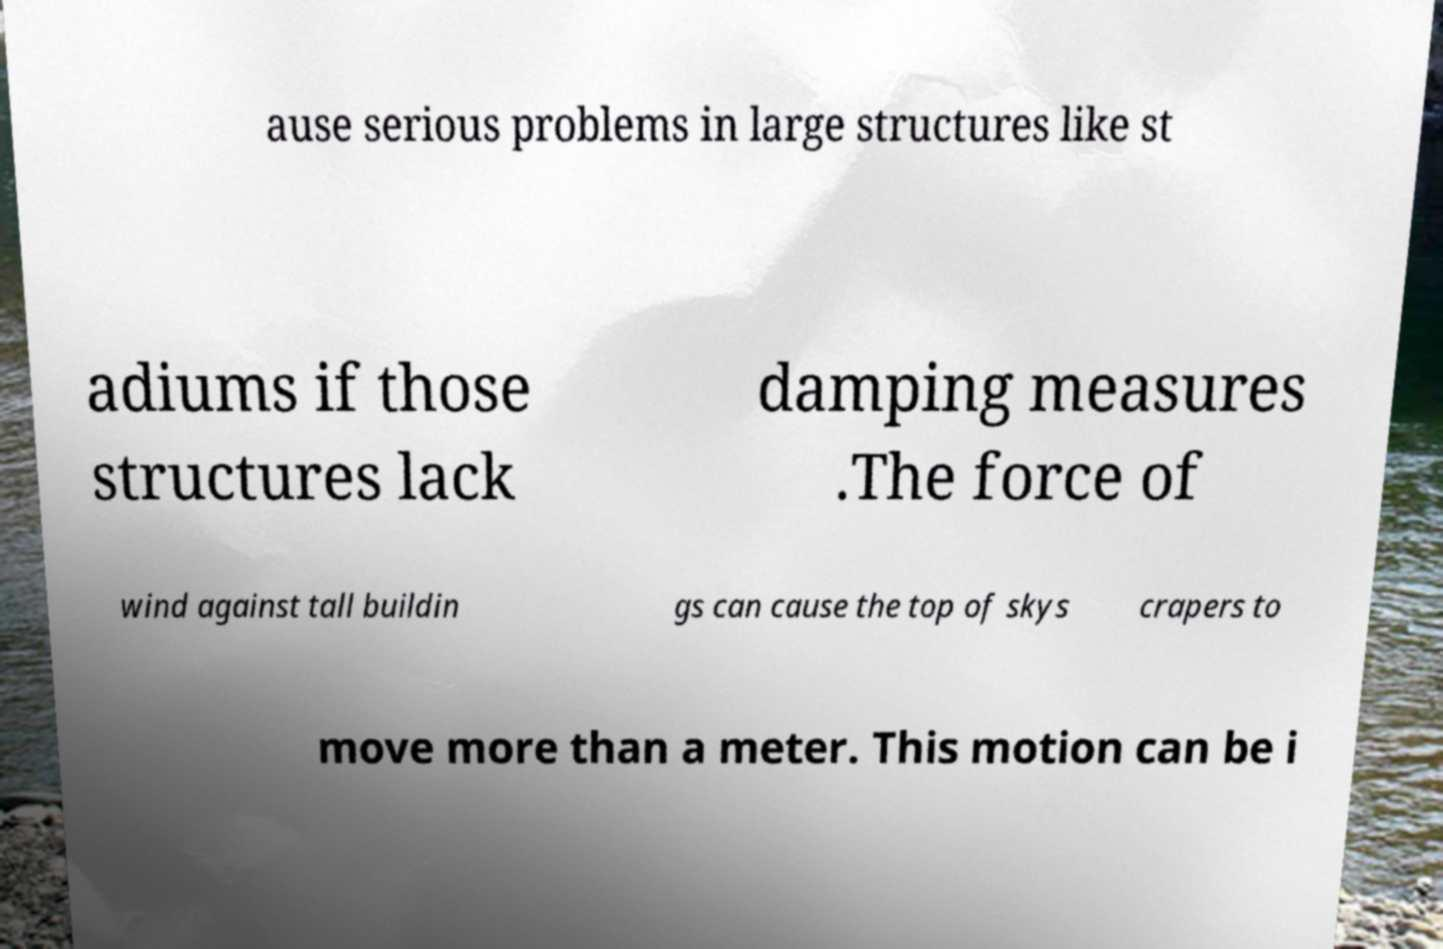Could you assist in decoding the text presented in this image and type it out clearly? ause serious problems in large structures like st adiums if those structures lack damping measures .The force of wind against tall buildin gs can cause the top of skys crapers to move more than a meter. This motion can be i 